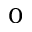Convert formula to latex. <formula><loc_0><loc_0><loc_500><loc_500>_ { 0 }</formula> 